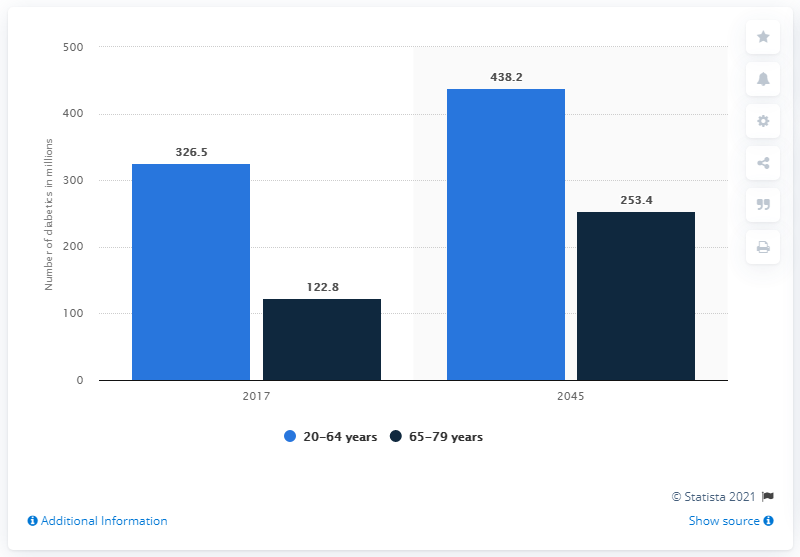Draw attention to some important aspects in this diagram. According to estimates, the number of people with diabetes is expected to reach 438.2 million by the year 2040. In 2017, an estimated 326.5 million people aged 20-64 years had diabetes. By the year 2040, it is projected that the number of people with diabetes will increase to 438 million. 